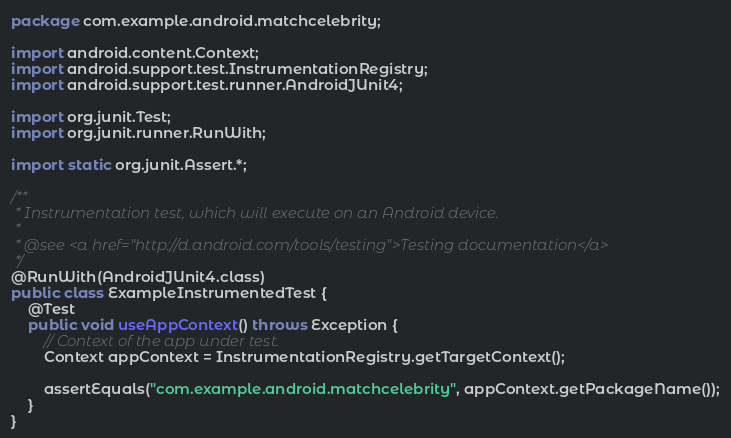<code> <loc_0><loc_0><loc_500><loc_500><_Java_>package com.example.android.matchcelebrity;

import android.content.Context;
import android.support.test.InstrumentationRegistry;
import android.support.test.runner.AndroidJUnit4;

import org.junit.Test;
import org.junit.runner.RunWith;

import static org.junit.Assert.*;

/**
 * Instrumentation test, which will execute on an Android device.
 *
 * @see <a href="http://d.android.com/tools/testing">Testing documentation</a>
 */
@RunWith(AndroidJUnit4.class)
public class ExampleInstrumentedTest {
    @Test
    public void useAppContext() throws Exception {
        // Context of the app under test.
        Context appContext = InstrumentationRegistry.getTargetContext();

        assertEquals("com.example.android.matchcelebrity", appContext.getPackageName());
    }
}
</code> 